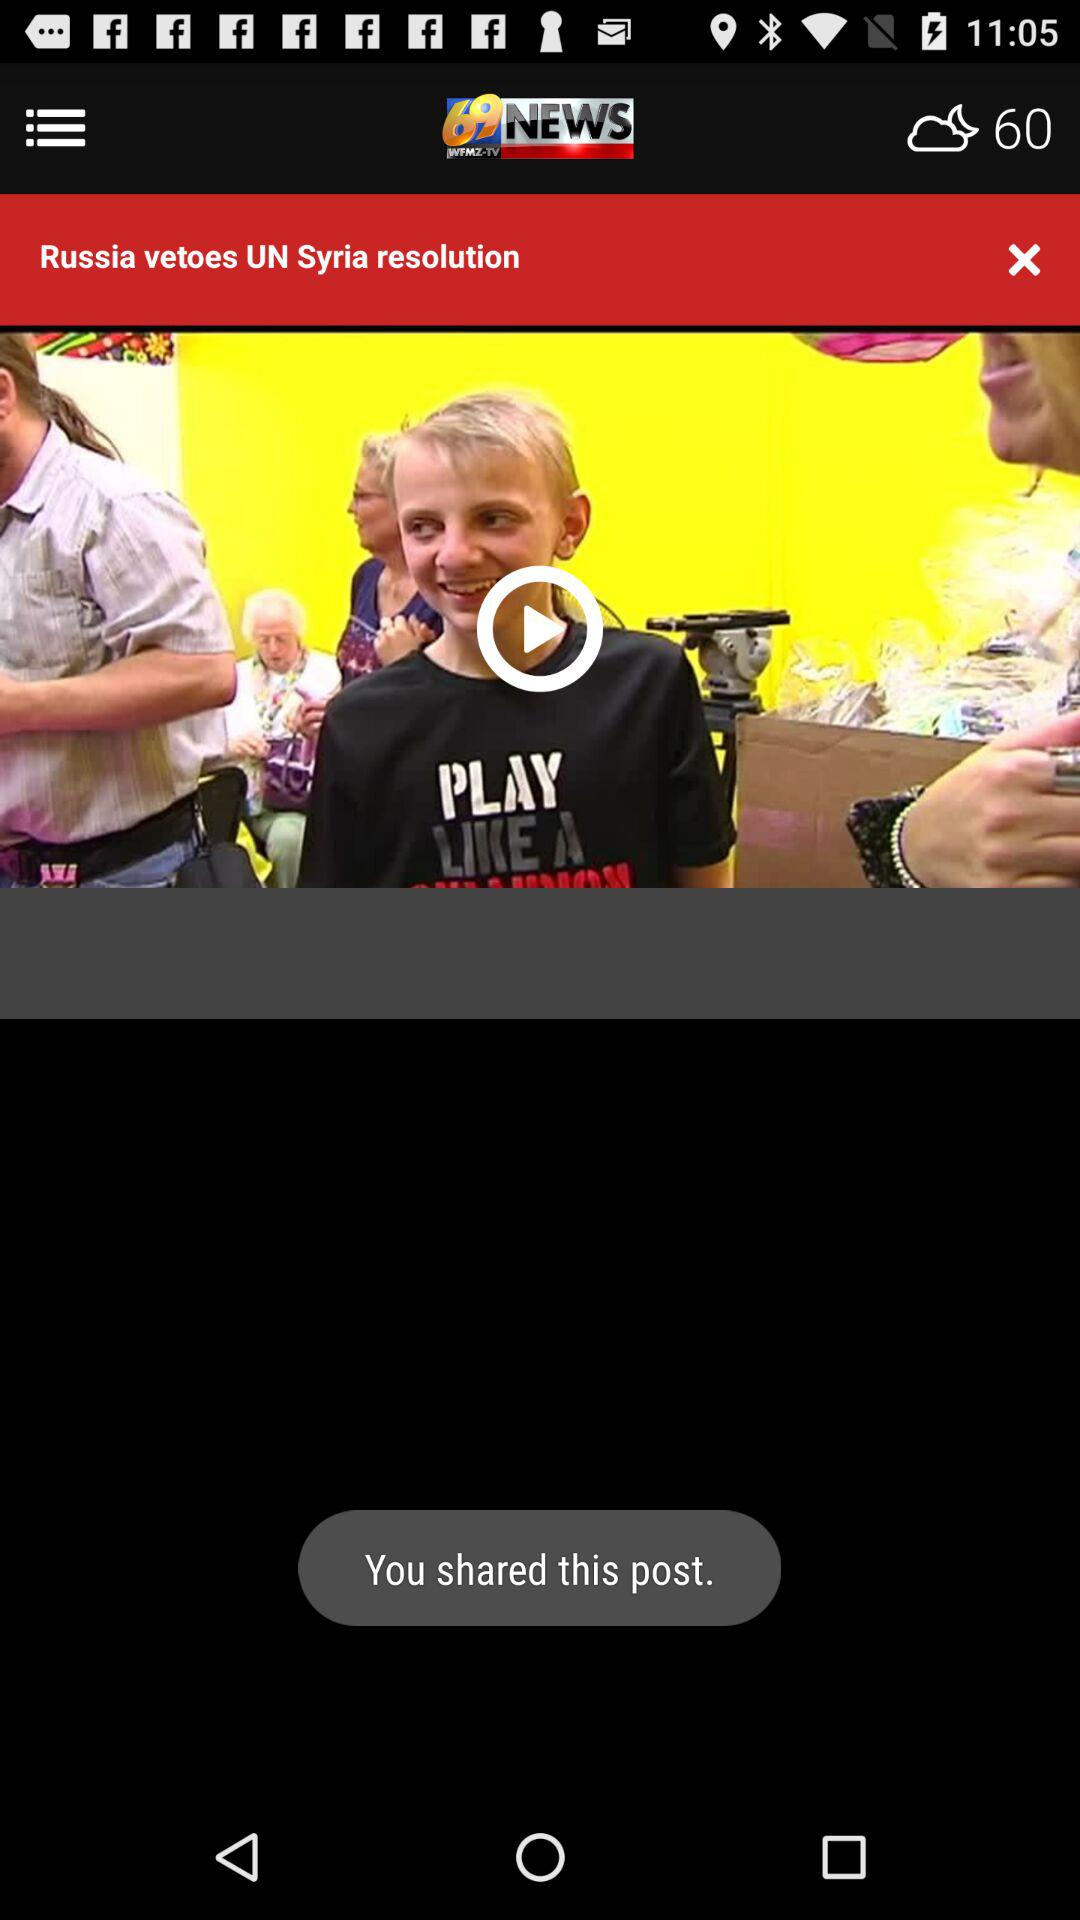How's the weather forecast? The weather forecast is for a cloudy night with a temperature of 60. 